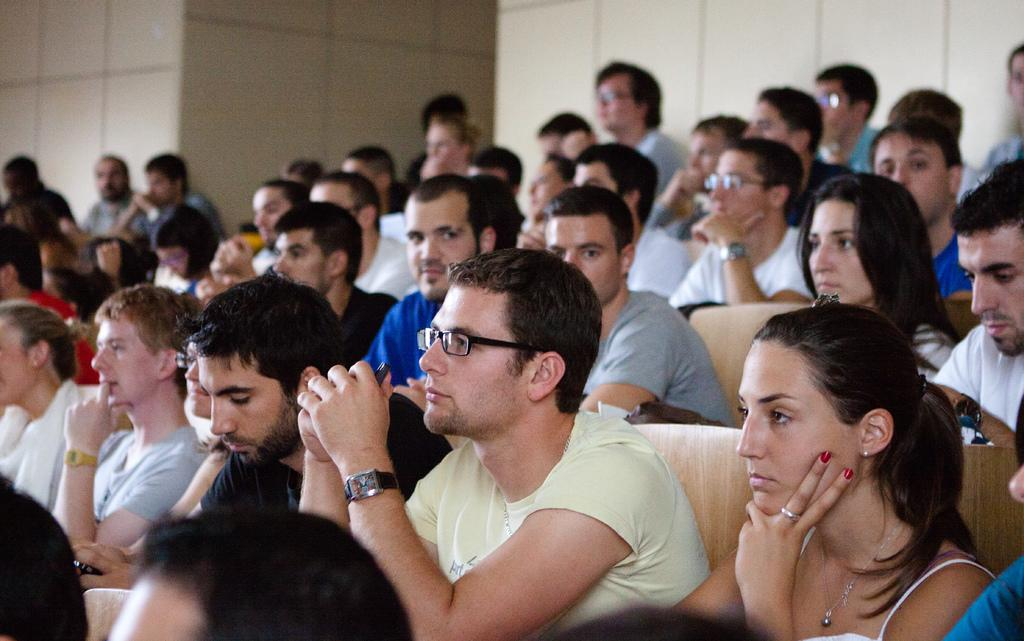What are the people in the image doing? The people in the image are sitting on chairs. Can you describe the quality of the image? The image is slightly blurred in some areas. What can be seen behind the people in the image? There is a wall visible in the image. What type of advice is the person in the image giving to the others? There is no indication in the image that anyone is giving advice to others. 